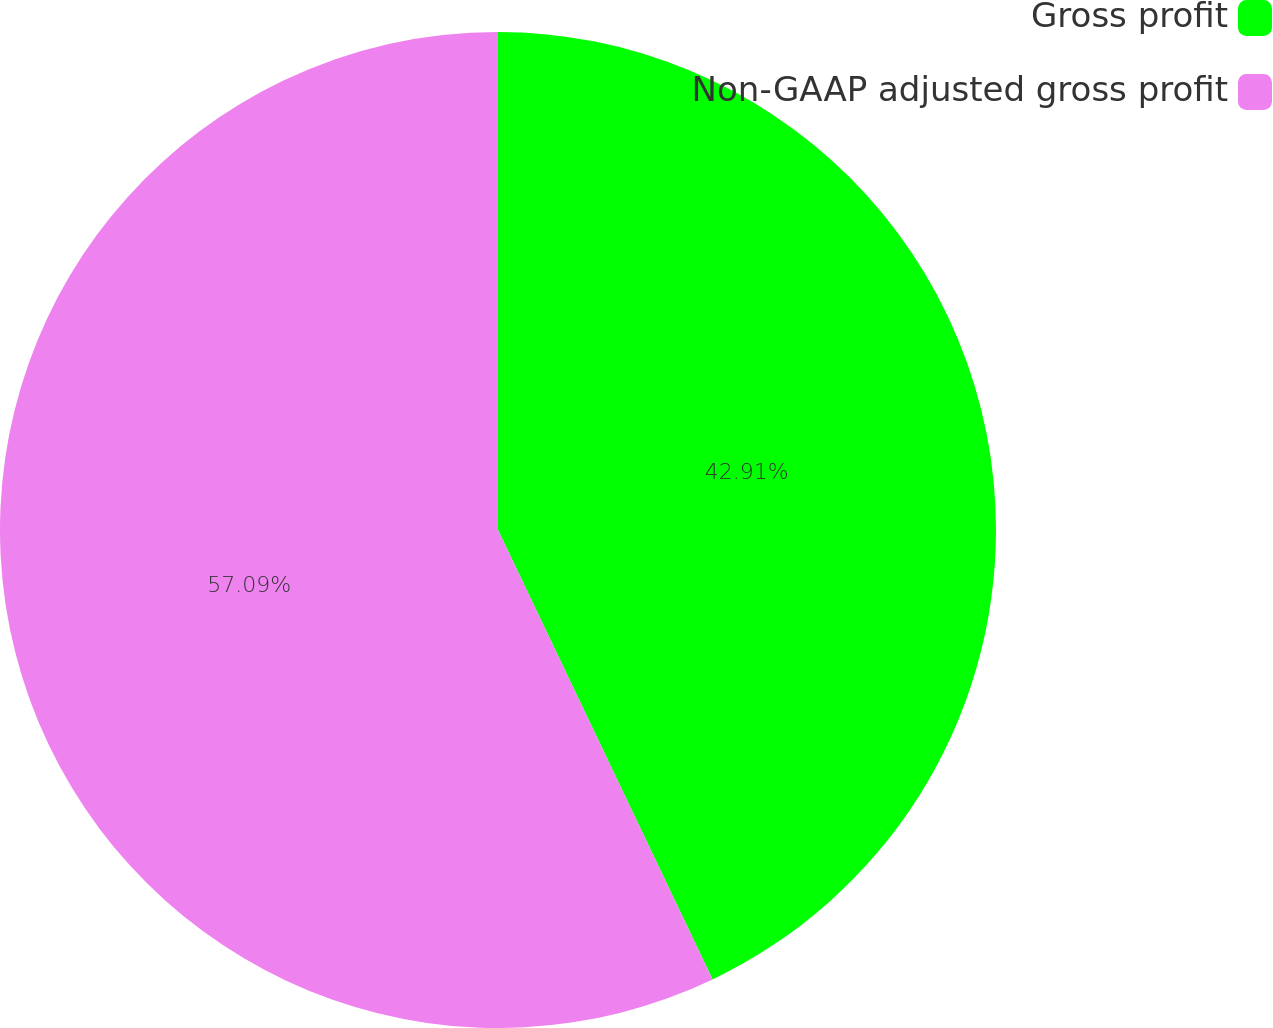Convert chart to OTSL. <chart><loc_0><loc_0><loc_500><loc_500><pie_chart><fcel>Gross profit<fcel>Non-GAAP adjusted gross profit<nl><fcel>42.91%<fcel>57.09%<nl></chart> 